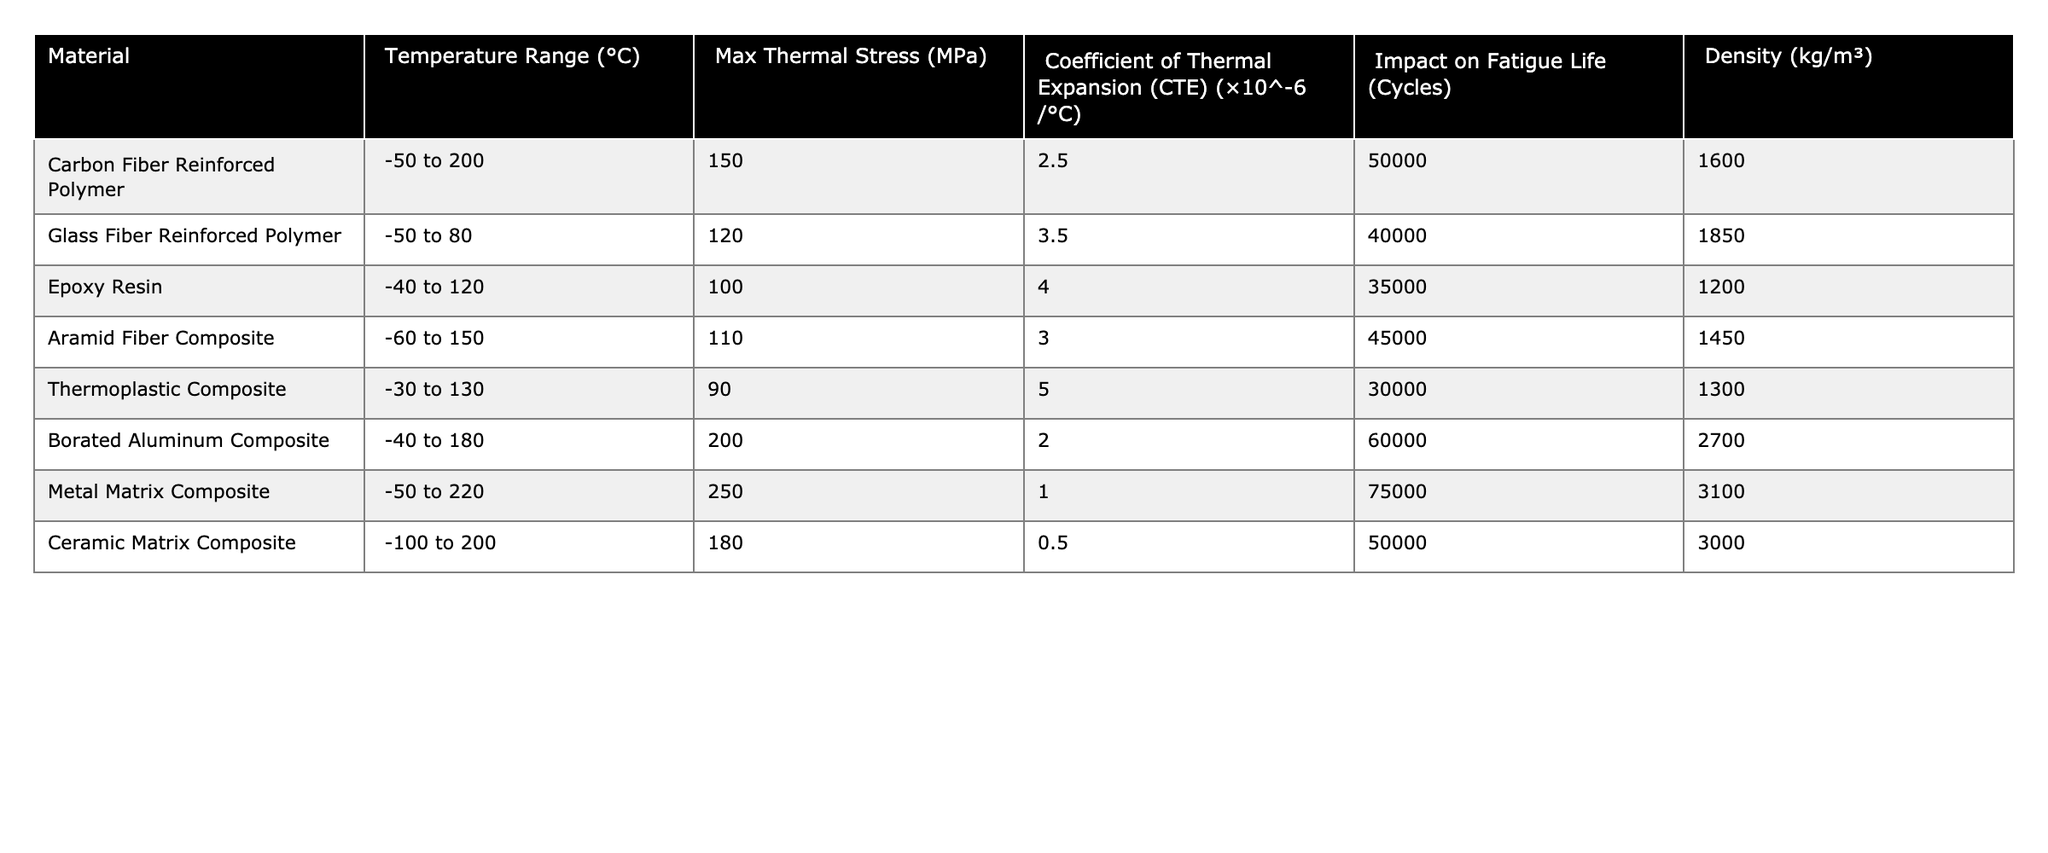What is the maximum thermal stress for Carbon Fiber Reinforced Polymer? The table lists the maximum thermal stress for each material, and for Carbon Fiber Reinforced Polymer, it is specified as 150 MPa.
Answer: 150 MPa Which material has the highest coefficient of thermal expansion? By checking the table, the coefficient of thermal expansion for each material is listed. The highest is for Thermoplastic Composite, which is 5.0 × 10^-6 /°C.
Answer: Thermoplastic Composite What is the density of Ceramic Matrix Composite? The table includes the density values for all materials, and the density for Ceramic Matrix Composite is given as 3000 kg/m³.
Answer: 3000 kg/m³ Which material has the lowest impact on fatigue life? The impact on fatigue life is noted for each material. The lowest value is for Thermoplastic Composite, reporting 30000 cycles.
Answer: Thermoplastic Composite Is the maximum thermal stress for Metal Matrix Composite greater than that for Glass Fiber Reinforced Polymer? Comparing the maximum thermal stresses, Metal Matrix Composite is 250 MPa and Glass Fiber Reinforced Polymer is 120 MPa. Therefore, Metal Matrix Composite has a greater stress.
Answer: Yes What is the average maximum thermal stress of the composite materials? To find the average, add all maximum thermal stress values: (150 + 120 + 100 + 110 + 90 + 200 + 250 + 180) = 1100 MPa. There are 8 materials, so the average is 1100/8 = 137.5 MPa.
Answer: 137.5 MPa Does Borated Aluminum Composite have a higher density than all other composites? Checking the density values, Borated Aluminum Composite has a density of 2700 kg/m³, which is higher than all listed densities except for Metal Matrix Composite, which has 3100 kg/m³. Therefore, it does not have the highest density.
Answer: No What is the difference in temperature range between the material with the highest thermal stress and the one with the lowest? The material with the highest stress is Metal Matrix Composite with a range of -50 to 220 °C, and the one with the lowest is Thermoplastic Composite with a range of -30 to 130 °C. The difference in range is 220 - (-50) = 270 °C and 130 - (-30) = 160 °C, leading to a difference of 270 - 160 = 110 °C.
Answer: 110 °C Which composite has the lowest maximum thermal stress, and what is it? By scanning the maximum thermal stress values, Thermoplastic Composite has the lowest maximum thermal stress at 90 MPa.
Answer: Thermoplastic Composite, 90 MPa How many composite materials have a maximum thermal stress greater than 150 MPa? Looking at the table, the materials that have a maximum thermal stress greater than 150 MPa are Metal Matrix Composite (250 MPa) and Borated Aluminum Composite (200 MPa). This totals 3 materials (Metal Matrix Composite, Borated Aluminum Composite, Carbon Fiber Reinforced Polymer).
Answer: 3 